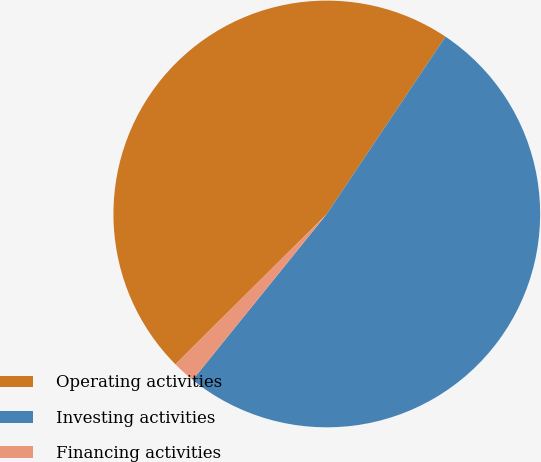<chart> <loc_0><loc_0><loc_500><loc_500><pie_chart><fcel>Operating activities<fcel>Investing activities<fcel>Financing activities<nl><fcel>46.84%<fcel>51.43%<fcel>1.73%<nl></chart> 